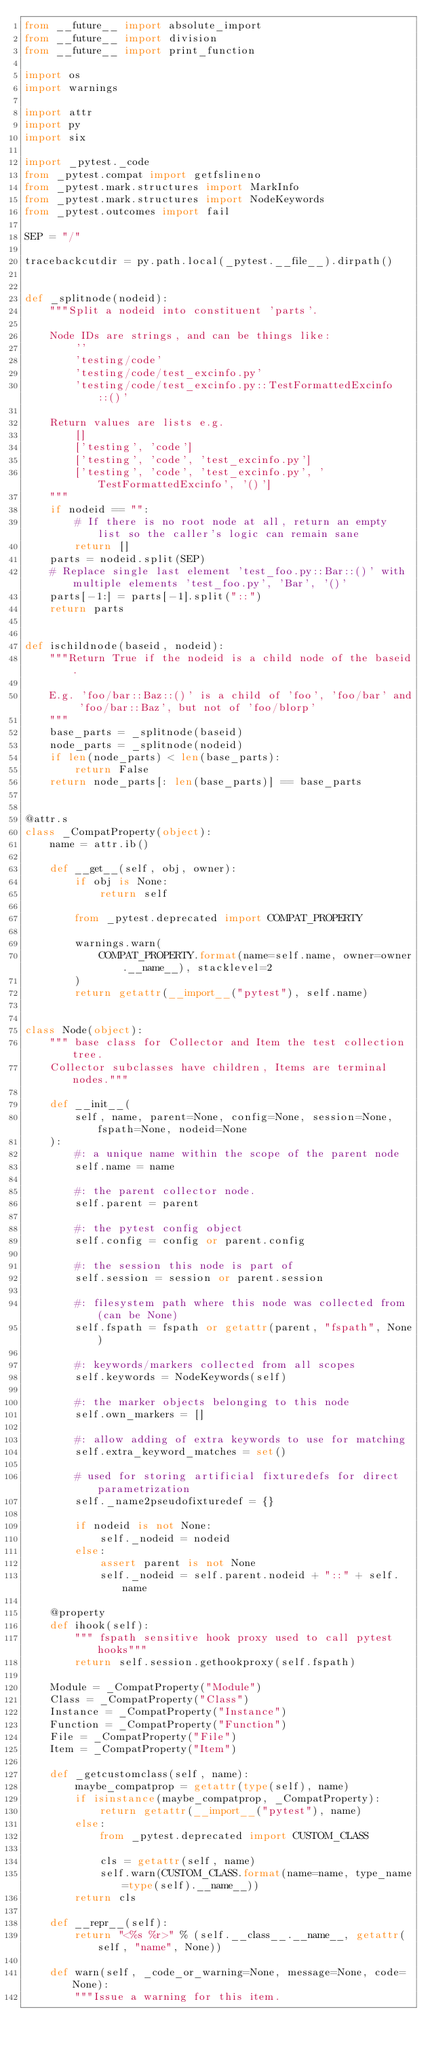<code> <loc_0><loc_0><loc_500><loc_500><_Python_>from __future__ import absolute_import
from __future__ import division
from __future__ import print_function

import os
import warnings

import attr
import py
import six

import _pytest._code
from _pytest.compat import getfslineno
from _pytest.mark.structures import MarkInfo
from _pytest.mark.structures import NodeKeywords
from _pytest.outcomes import fail

SEP = "/"

tracebackcutdir = py.path.local(_pytest.__file__).dirpath()


def _splitnode(nodeid):
    """Split a nodeid into constituent 'parts'.

    Node IDs are strings, and can be things like:
        ''
        'testing/code'
        'testing/code/test_excinfo.py'
        'testing/code/test_excinfo.py::TestFormattedExcinfo::()'

    Return values are lists e.g.
        []
        ['testing', 'code']
        ['testing', 'code', 'test_excinfo.py']
        ['testing', 'code', 'test_excinfo.py', 'TestFormattedExcinfo', '()']
    """
    if nodeid == "":
        # If there is no root node at all, return an empty list so the caller's logic can remain sane
        return []
    parts = nodeid.split(SEP)
    # Replace single last element 'test_foo.py::Bar::()' with multiple elements 'test_foo.py', 'Bar', '()'
    parts[-1:] = parts[-1].split("::")
    return parts


def ischildnode(baseid, nodeid):
    """Return True if the nodeid is a child node of the baseid.

    E.g. 'foo/bar::Baz::()' is a child of 'foo', 'foo/bar' and 'foo/bar::Baz', but not of 'foo/blorp'
    """
    base_parts = _splitnode(baseid)
    node_parts = _splitnode(nodeid)
    if len(node_parts) < len(base_parts):
        return False
    return node_parts[: len(base_parts)] == base_parts


@attr.s
class _CompatProperty(object):
    name = attr.ib()

    def __get__(self, obj, owner):
        if obj is None:
            return self

        from _pytest.deprecated import COMPAT_PROPERTY

        warnings.warn(
            COMPAT_PROPERTY.format(name=self.name, owner=owner.__name__), stacklevel=2
        )
        return getattr(__import__("pytest"), self.name)


class Node(object):
    """ base class for Collector and Item the test collection tree.
    Collector subclasses have children, Items are terminal nodes."""

    def __init__(
        self, name, parent=None, config=None, session=None, fspath=None, nodeid=None
    ):
        #: a unique name within the scope of the parent node
        self.name = name

        #: the parent collector node.
        self.parent = parent

        #: the pytest config object
        self.config = config or parent.config

        #: the session this node is part of
        self.session = session or parent.session

        #: filesystem path where this node was collected from (can be None)
        self.fspath = fspath or getattr(parent, "fspath", None)

        #: keywords/markers collected from all scopes
        self.keywords = NodeKeywords(self)

        #: the marker objects belonging to this node
        self.own_markers = []

        #: allow adding of extra keywords to use for matching
        self.extra_keyword_matches = set()

        # used for storing artificial fixturedefs for direct parametrization
        self._name2pseudofixturedef = {}

        if nodeid is not None:
            self._nodeid = nodeid
        else:
            assert parent is not None
            self._nodeid = self.parent.nodeid + "::" + self.name

    @property
    def ihook(self):
        """ fspath sensitive hook proxy used to call pytest hooks"""
        return self.session.gethookproxy(self.fspath)

    Module = _CompatProperty("Module")
    Class = _CompatProperty("Class")
    Instance = _CompatProperty("Instance")
    Function = _CompatProperty("Function")
    File = _CompatProperty("File")
    Item = _CompatProperty("Item")

    def _getcustomclass(self, name):
        maybe_compatprop = getattr(type(self), name)
        if isinstance(maybe_compatprop, _CompatProperty):
            return getattr(__import__("pytest"), name)
        else:
            from _pytest.deprecated import CUSTOM_CLASS

            cls = getattr(self, name)
            self.warn(CUSTOM_CLASS.format(name=name, type_name=type(self).__name__))
        return cls

    def __repr__(self):
        return "<%s %r>" % (self.__class__.__name__, getattr(self, "name", None))

    def warn(self, _code_or_warning=None, message=None, code=None):
        """Issue a warning for this item.
</code> 